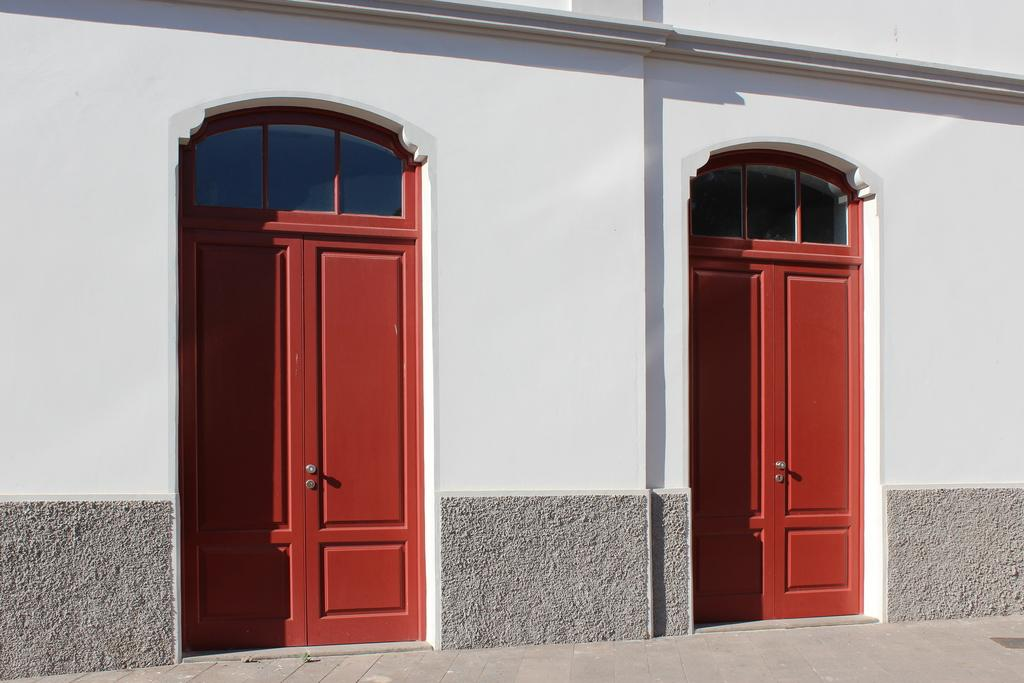What type of structure is visible in the image? There is a building in the image. How many doors can be seen on the building? There are two doors in the image. What color is the wall next to the building? There is a white wall in the image. What is located at the bottom of the image? There is a road at the bottom of the image. Can you tell me how many goldfish are swimming in the building's fountain in the image? There is no fountain or goldfish present in the image. What type of creature can be seen interacting with the doors in the image? There are no creatures visible in the image; only the building, doors, wall, and road are present. 